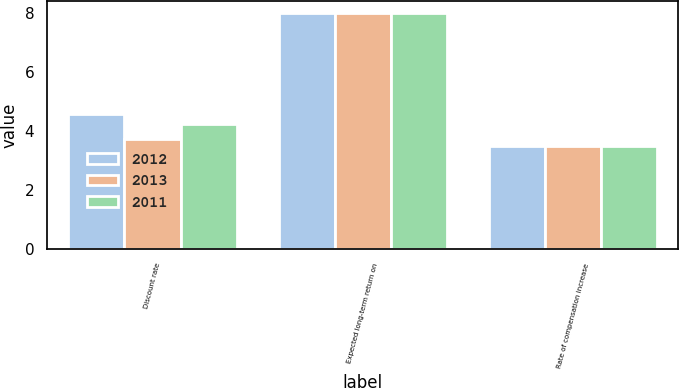Convert chart to OTSL. <chart><loc_0><loc_0><loc_500><loc_500><stacked_bar_chart><ecel><fcel>Discount rate<fcel>Expected long-term return on<fcel>Rate of compensation increase<nl><fcel>2012<fcel>4.6<fcel>8<fcel>3.5<nl><fcel>2013<fcel>3.75<fcel>8<fcel>3.5<nl><fcel>2011<fcel>4.25<fcel>8<fcel>3.5<nl></chart> 